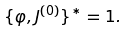Convert formula to latex. <formula><loc_0><loc_0><loc_500><loc_500>\{ \varphi , J ^ { ( 0 ) } \} ^ { * } = 1 .</formula> 